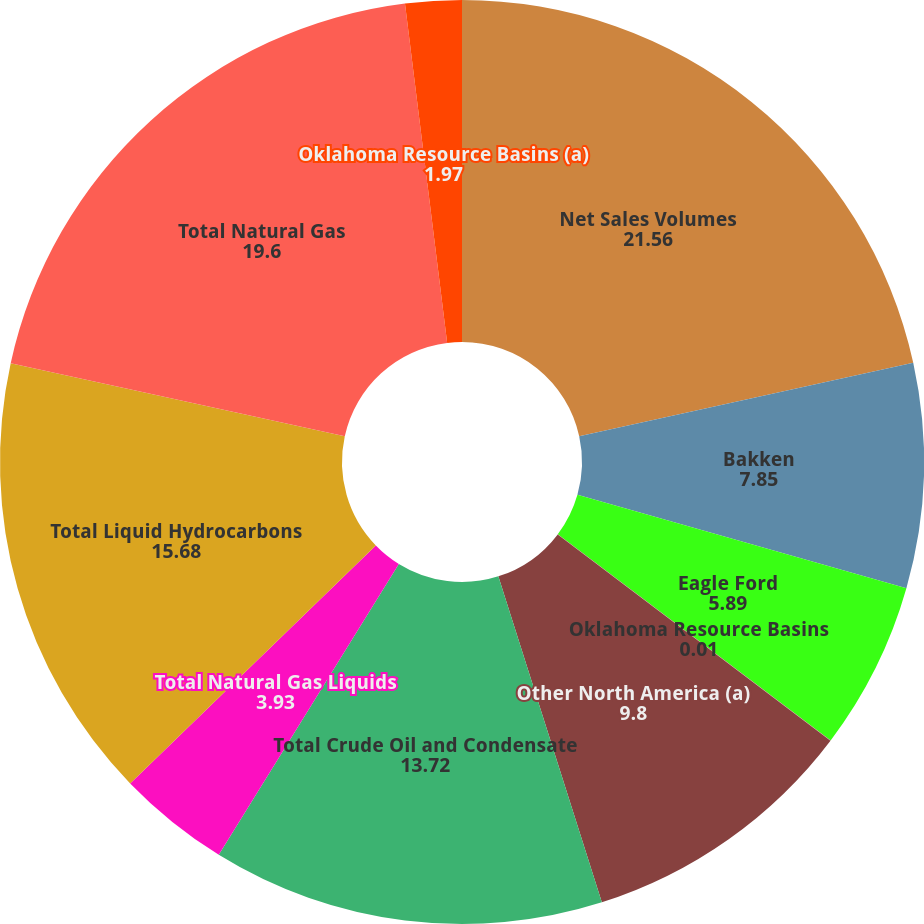Convert chart to OTSL. <chart><loc_0><loc_0><loc_500><loc_500><pie_chart><fcel>Net Sales Volumes<fcel>Bakken<fcel>Eagle Ford<fcel>Oklahoma Resource Basins<fcel>Other North America (a)<fcel>Total Crude Oil and Condensate<fcel>Total Natural Gas Liquids<fcel>Total Liquid Hydrocarbons<fcel>Total Natural Gas<fcel>Oklahoma Resource Basins (a)<nl><fcel>21.56%<fcel>7.85%<fcel>5.89%<fcel>0.01%<fcel>9.8%<fcel>13.72%<fcel>3.93%<fcel>15.68%<fcel>19.6%<fcel>1.97%<nl></chart> 